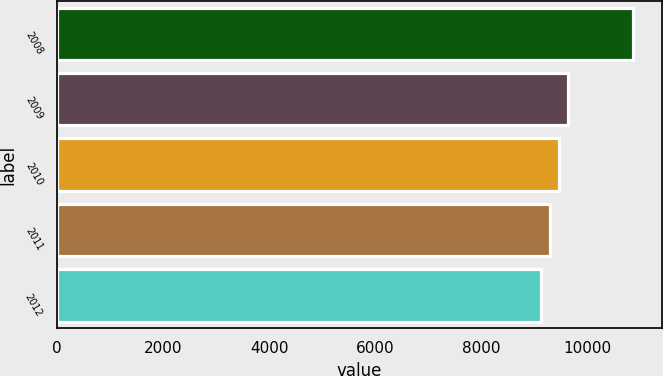<chart> <loc_0><loc_0><loc_500><loc_500><bar_chart><fcel>2008<fcel>2009<fcel>2010<fcel>2011<fcel>2012<nl><fcel>10862<fcel>9645.4<fcel>9471.6<fcel>9297.8<fcel>9124<nl></chart> 